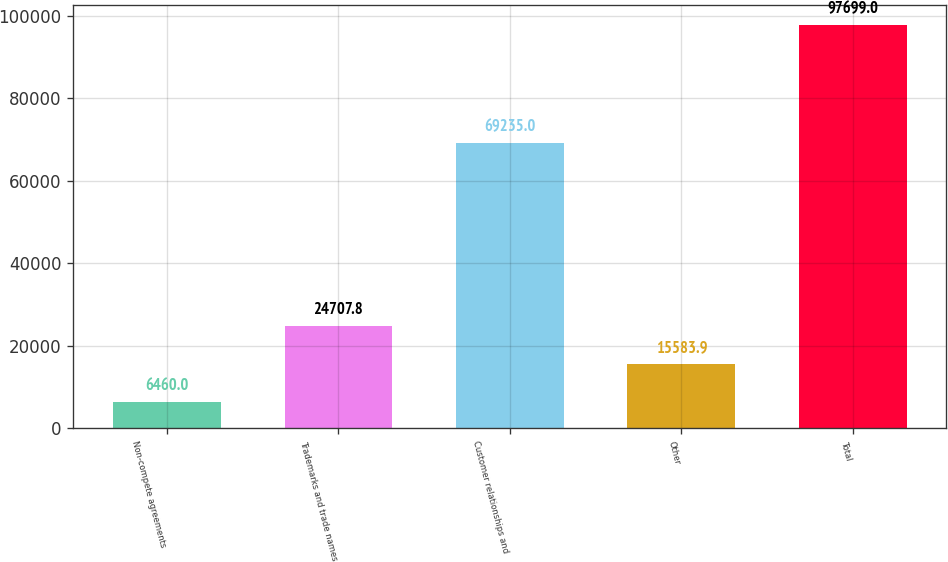Convert chart. <chart><loc_0><loc_0><loc_500><loc_500><bar_chart><fcel>Non-compete agreements<fcel>Trademarks and trade names<fcel>Customer relationships and<fcel>Other<fcel>Total<nl><fcel>6460<fcel>24707.8<fcel>69235<fcel>15583.9<fcel>97699<nl></chart> 